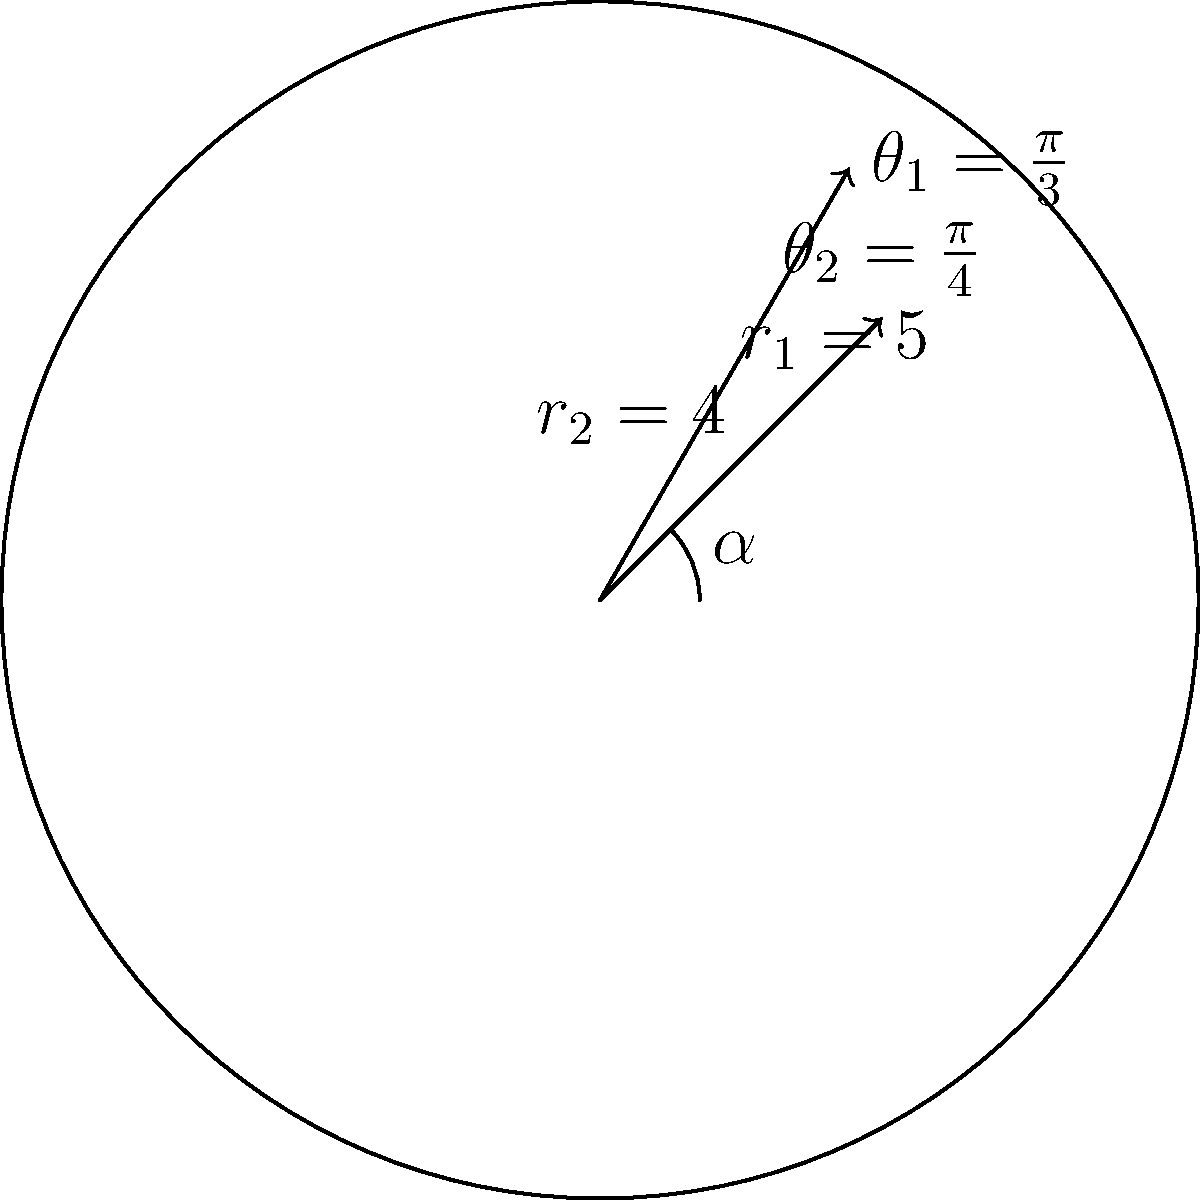You're comparing two mortgage payment options represented as vectors in polar form. Option 1 has a magnitude of $5$ (representing $500 monthly) and an angle of $\frac{\pi}{3}$ radians, while Option 2 has a magnitude of $4$ (representing $400 monthly) and an angle of $\frac{\pi}{4}$ radians. What is the angle $\alpha$ between these two options? To find the angle between two vectors in polar form, we can use the following steps:

1) First, recall the formula for the angle between two vectors in polar form:

   $\cos(\alpha) = \cos(\theta_1)\cos(\theta_2) + \sin(\theta_1)\sin(\theta_2)$

2) We're given:
   $\theta_1 = \frac{\pi}{3}$ and $\theta_2 = \frac{\pi}{4}$

3) Let's calculate each term:
   $\cos(\frac{\pi}{3}) = \frac{1}{2}$
   $\cos(\frac{\pi}{4}) = \frac{\sqrt{2}}{2}$
   $\sin(\frac{\pi}{3}) = \frac{\sqrt{3}}{2}$
   $\sin(\frac{\pi}{4}) = \frac{\sqrt{2}}{2}$

4) Now, let's substitute these values into our formula:

   $\cos(\alpha) = (\frac{1}{2})(\frac{\sqrt{2}}{2}) + (\frac{\sqrt{3}}{2})(\frac{\sqrt{2}}{2})$

5) Simplify:
   $\cos(\alpha) = \frac{\sqrt{2}}{4} + \frac{\sqrt{6}}{4} = \frac{\sqrt{2} + \sqrt{6}}{4}$

6) To find $\alpha$, we need to take the inverse cosine (arccos) of both sides:

   $\alpha = \arccos(\frac{\sqrt{2} + \sqrt{6}}{4})$

7) Using a calculator or computer, we can evaluate this:

   $\alpha \approx 0.2731$ radians

8) Convert to degrees:
   $0.2731 \text{ radians} \times \frac{180^{\circ}}{\pi} \approx 15.64^{\circ}$
Answer: $15.64^{\circ}$ 